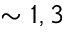Convert formula to latex. <formula><loc_0><loc_0><loc_500><loc_500>\sim 1 , 3</formula> 